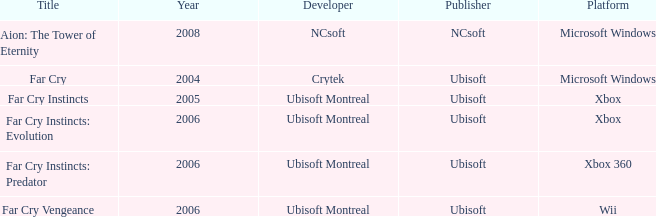Which title has xbox as the platform with a year prior to 2006? Far Cry Instincts. Help me parse the entirety of this table. {'header': ['Title', 'Year', 'Developer', 'Publisher', 'Platform'], 'rows': [['Aion: The Tower of Eternity', '2008', 'NCsoft', 'NCsoft', 'Microsoft Windows'], ['Far Cry', '2004', 'Crytek', 'Ubisoft', 'Microsoft Windows'], ['Far Cry Instincts', '2005', 'Ubisoft Montreal', 'Ubisoft', 'Xbox'], ['Far Cry Instincts: Evolution', '2006', 'Ubisoft Montreal', 'Ubisoft', 'Xbox'], ['Far Cry Instincts: Predator', '2006', 'Ubisoft Montreal', 'Ubisoft', 'Xbox 360'], ['Far Cry Vengeance', '2006', 'Ubisoft Montreal', 'Ubisoft', 'Wii']]} 